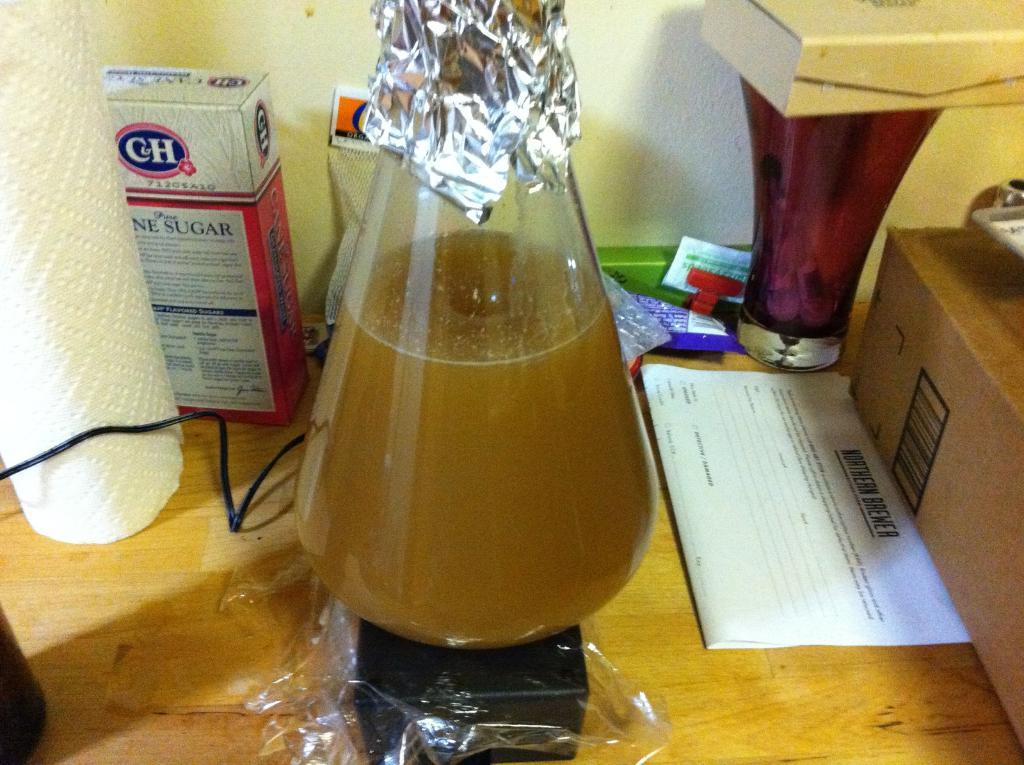Provide a one-sentence caption for the provided image. A box of "C&H" cane sugar sits behind a flask. 